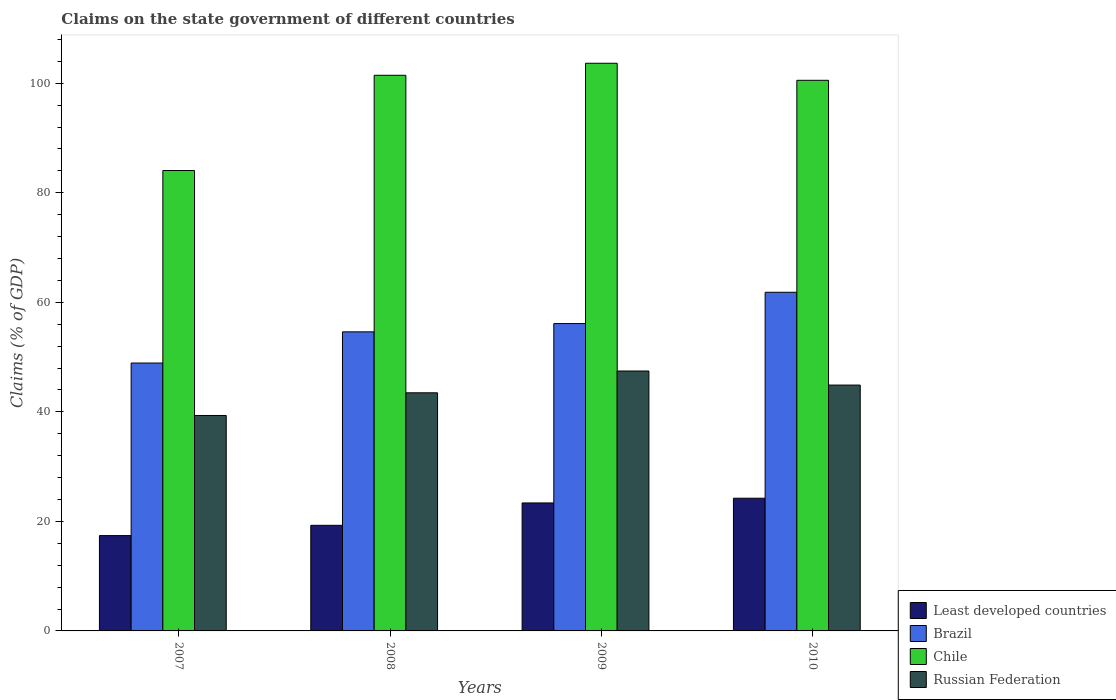How many groups of bars are there?
Keep it short and to the point. 4. Are the number of bars per tick equal to the number of legend labels?
Give a very brief answer. Yes. In how many cases, is the number of bars for a given year not equal to the number of legend labels?
Give a very brief answer. 0. What is the percentage of GDP claimed on the state government in Brazil in 2010?
Provide a short and direct response. 61.83. Across all years, what is the maximum percentage of GDP claimed on the state government in Chile?
Your answer should be compact. 103.65. Across all years, what is the minimum percentage of GDP claimed on the state government in Least developed countries?
Ensure brevity in your answer.  17.41. In which year was the percentage of GDP claimed on the state government in Brazil minimum?
Offer a very short reply. 2007. What is the total percentage of GDP claimed on the state government in Russian Federation in the graph?
Offer a very short reply. 175.15. What is the difference between the percentage of GDP claimed on the state government in Least developed countries in 2009 and that in 2010?
Provide a succinct answer. -0.86. What is the difference between the percentage of GDP claimed on the state government in Brazil in 2007 and the percentage of GDP claimed on the state government in Russian Federation in 2010?
Your answer should be very brief. 4.02. What is the average percentage of GDP claimed on the state government in Chile per year?
Provide a short and direct response. 97.42. In the year 2009, what is the difference between the percentage of GDP claimed on the state government in Chile and percentage of GDP claimed on the state government in Brazil?
Provide a short and direct response. 47.53. What is the ratio of the percentage of GDP claimed on the state government in Chile in 2008 to that in 2010?
Provide a short and direct response. 1.01. Is the percentage of GDP claimed on the state government in Chile in 2007 less than that in 2010?
Make the answer very short. Yes. What is the difference between the highest and the second highest percentage of GDP claimed on the state government in Brazil?
Offer a terse response. 5.71. What is the difference between the highest and the lowest percentage of GDP claimed on the state government in Brazil?
Offer a terse response. 12.92. In how many years, is the percentage of GDP claimed on the state government in Chile greater than the average percentage of GDP claimed on the state government in Chile taken over all years?
Provide a succinct answer. 3. Is the sum of the percentage of GDP claimed on the state government in Brazil in 2007 and 2008 greater than the maximum percentage of GDP claimed on the state government in Least developed countries across all years?
Your answer should be compact. Yes. What does the 1st bar from the left in 2008 represents?
Provide a short and direct response. Least developed countries. Are all the bars in the graph horizontal?
Your answer should be very brief. No. What is the difference between two consecutive major ticks on the Y-axis?
Ensure brevity in your answer.  20. Are the values on the major ticks of Y-axis written in scientific E-notation?
Make the answer very short. No. Does the graph contain any zero values?
Ensure brevity in your answer.  No. What is the title of the graph?
Offer a terse response. Claims on the state government of different countries. What is the label or title of the Y-axis?
Ensure brevity in your answer.  Claims (% of GDP). What is the Claims (% of GDP) of Least developed countries in 2007?
Your answer should be compact. 17.41. What is the Claims (% of GDP) of Brazil in 2007?
Provide a short and direct response. 48.91. What is the Claims (% of GDP) in Chile in 2007?
Keep it short and to the point. 84.06. What is the Claims (% of GDP) in Russian Federation in 2007?
Provide a succinct answer. 39.34. What is the Claims (% of GDP) of Least developed countries in 2008?
Your answer should be compact. 19.28. What is the Claims (% of GDP) of Brazil in 2008?
Your answer should be compact. 54.61. What is the Claims (% of GDP) of Chile in 2008?
Your response must be concise. 101.45. What is the Claims (% of GDP) in Russian Federation in 2008?
Your response must be concise. 43.48. What is the Claims (% of GDP) in Least developed countries in 2009?
Your answer should be compact. 23.37. What is the Claims (% of GDP) of Brazil in 2009?
Your answer should be very brief. 56.12. What is the Claims (% of GDP) in Chile in 2009?
Provide a succinct answer. 103.65. What is the Claims (% of GDP) in Russian Federation in 2009?
Make the answer very short. 47.45. What is the Claims (% of GDP) in Least developed countries in 2010?
Provide a short and direct response. 24.23. What is the Claims (% of GDP) of Brazil in 2010?
Offer a terse response. 61.83. What is the Claims (% of GDP) of Chile in 2010?
Give a very brief answer. 100.53. What is the Claims (% of GDP) in Russian Federation in 2010?
Provide a succinct answer. 44.89. Across all years, what is the maximum Claims (% of GDP) in Least developed countries?
Ensure brevity in your answer.  24.23. Across all years, what is the maximum Claims (% of GDP) of Brazil?
Your response must be concise. 61.83. Across all years, what is the maximum Claims (% of GDP) of Chile?
Make the answer very short. 103.65. Across all years, what is the maximum Claims (% of GDP) in Russian Federation?
Your answer should be very brief. 47.45. Across all years, what is the minimum Claims (% of GDP) in Least developed countries?
Ensure brevity in your answer.  17.41. Across all years, what is the minimum Claims (% of GDP) in Brazil?
Ensure brevity in your answer.  48.91. Across all years, what is the minimum Claims (% of GDP) of Chile?
Make the answer very short. 84.06. Across all years, what is the minimum Claims (% of GDP) in Russian Federation?
Offer a terse response. 39.34. What is the total Claims (% of GDP) in Least developed countries in the graph?
Make the answer very short. 84.28. What is the total Claims (% of GDP) of Brazil in the graph?
Offer a very short reply. 221.47. What is the total Claims (% of GDP) in Chile in the graph?
Provide a succinct answer. 389.69. What is the total Claims (% of GDP) in Russian Federation in the graph?
Your answer should be very brief. 175.15. What is the difference between the Claims (% of GDP) in Least developed countries in 2007 and that in 2008?
Your answer should be very brief. -1.88. What is the difference between the Claims (% of GDP) in Brazil in 2007 and that in 2008?
Your answer should be very brief. -5.69. What is the difference between the Claims (% of GDP) in Chile in 2007 and that in 2008?
Make the answer very short. -17.39. What is the difference between the Claims (% of GDP) of Russian Federation in 2007 and that in 2008?
Provide a short and direct response. -4.14. What is the difference between the Claims (% of GDP) of Least developed countries in 2007 and that in 2009?
Offer a terse response. -5.96. What is the difference between the Claims (% of GDP) in Brazil in 2007 and that in 2009?
Make the answer very short. -7.2. What is the difference between the Claims (% of GDP) of Chile in 2007 and that in 2009?
Offer a very short reply. -19.58. What is the difference between the Claims (% of GDP) in Russian Federation in 2007 and that in 2009?
Provide a succinct answer. -8.12. What is the difference between the Claims (% of GDP) in Least developed countries in 2007 and that in 2010?
Your answer should be compact. -6.82. What is the difference between the Claims (% of GDP) in Brazil in 2007 and that in 2010?
Provide a short and direct response. -12.92. What is the difference between the Claims (% of GDP) in Chile in 2007 and that in 2010?
Give a very brief answer. -16.47. What is the difference between the Claims (% of GDP) of Russian Federation in 2007 and that in 2010?
Your response must be concise. -5.55. What is the difference between the Claims (% of GDP) in Least developed countries in 2008 and that in 2009?
Make the answer very short. -4.08. What is the difference between the Claims (% of GDP) in Brazil in 2008 and that in 2009?
Provide a succinct answer. -1.51. What is the difference between the Claims (% of GDP) of Chile in 2008 and that in 2009?
Provide a succinct answer. -2.19. What is the difference between the Claims (% of GDP) of Russian Federation in 2008 and that in 2009?
Your response must be concise. -3.98. What is the difference between the Claims (% of GDP) of Least developed countries in 2008 and that in 2010?
Your answer should be compact. -4.95. What is the difference between the Claims (% of GDP) of Brazil in 2008 and that in 2010?
Offer a terse response. -7.23. What is the difference between the Claims (% of GDP) in Chile in 2008 and that in 2010?
Provide a short and direct response. 0.92. What is the difference between the Claims (% of GDP) in Russian Federation in 2008 and that in 2010?
Provide a succinct answer. -1.41. What is the difference between the Claims (% of GDP) of Least developed countries in 2009 and that in 2010?
Your response must be concise. -0.86. What is the difference between the Claims (% of GDP) of Brazil in 2009 and that in 2010?
Offer a terse response. -5.71. What is the difference between the Claims (% of GDP) in Chile in 2009 and that in 2010?
Ensure brevity in your answer.  3.11. What is the difference between the Claims (% of GDP) of Russian Federation in 2009 and that in 2010?
Your response must be concise. 2.57. What is the difference between the Claims (% of GDP) of Least developed countries in 2007 and the Claims (% of GDP) of Brazil in 2008?
Your answer should be compact. -37.2. What is the difference between the Claims (% of GDP) in Least developed countries in 2007 and the Claims (% of GDP) in Chile in 2008?
Provide a succinct answer. -84.05. What is the difference between the Claims (% of GDP) of Least developed countries in 2007 and the Claims (% of GDP) of Russian Federation in 2008?
Provide a succinct answer. -26.07. What is the difference between the Claims (% of GDP) in Brazil in 2007 and the Claims (% of GDP) in Chile in 2008?
Offer a very short reply. -52.54. What is the difference between the Claims (% of GDP) in Brazil in 2007 and the Claims (% of GDP) in Russian Federation in 2008?
Offer a terse response. 5.44. What is the difference between the Claims (% of GDP) of Chile in 2007 and the Claims (% of GDP) of Russian Federation in 2008?
Your answer should be compact. 40.59. What is the difference between the Claims (% of GDP) in Least developed countries in 2007 and the Claims (% of GDP) in Brazil in 2009?
Ensure brevity in your answer.  -38.71. What is the difference between the Claims (% of GDP) of Least developed countries in 2007 and the Claims (% of GDP) of Chile in 2009?
Your response must be concise. -86.24. What is the difference between the Claims (% of GDP) of Least developed countries in 2007 and the Claims (% of GDP) of Russian Federation in 2009?
Give a very brief answer. -30.05. What is the difference between the Claims (% of GDP) in Brazil in 2007 and the Claims (% of GDP) in Chile in 2009?
Provide a short and direct response. -54.73. What is the difference between the Claims (% of GDP) of Brazil in 2007 and the Claims (% of GDP) of Russian Federation in 2009?
Your answer should be compact. 1.46. What is the difference between the Claims (% of GDP) of Chile in 2007 and the Claims (% of GDP) of Russian Federation in 2009?
Your answer should be compact. 36.61. What is the difference between the Claims (% of GDP) in Least developed countries in 2007 and the Claims (% of GDP) in Brazil in 2010?
Your response must be concise. -44.42. What is the difference between the Claims (% of GDP) of Least developed countries in 2007 and the Claims (% of GDP) of Chile in 2010?
Make the answer very short. -83.13. What is the difference between the Claims (% of GDP) in Least developed countries in 2007 and the Claims (% of GDP) in Russian Federation in 2010?
Provide a succinct answer. -27.48. What is the difference between the Claims (% of GDP) of Brazil in 2007 and the Claims (% of GDP) of Chile in 2010?
Provide a succinct answer. -51.62. What is the difference between the Claims (% of GDP) of Brazil in 2007 and the Claims (% of GDP) of Russian Federation in 2010?
Provide a succinct answer. 4.02. What is the difference between the Claims (% of GDP) of Chile in 2007 and the Claims (% of GDP) of Russian Federation in 2010?
Give a very brief answer. 39.17. What is the difference between the Claims (% of GDP) of Least developed countries in 2008 and the Claims (% of GDP) of Brazil in 2009?
Offer a terse response. -36.84. What is the difference between the Claims (% of GDP) in Least developed countries in 2008 and the Claims (% of GDP) in Chile in 2009?
Your answer should be compact. -84.36. What is the difference between the Claims (% of GDP) in Least developed countries in 2008 and the Claims (% of GDP) in Russian Federation in 2009?
Your response must be concise. -28.17. What is the difference between the Claims (% of GDP) in Brazil in 2008 and the Claims (% of GDP) in Chile in 2009?
Make the answer very short. -49.04. What is the difference between the Claims (% of GDP) in Brazil in 2008 and the Claims (% of GDP) in Russian Federation in 2009?
Make the answer very short. 7.15. What is the difference between the Claims (% of GDP) in Chile in 2008 and the Claims (% of GDP) in Russian Federation in 2009?
Your answer should be very brief. 54. What is the difference between the Claims (% of GDP) in Least developed countries in 2008 and the Claims (% of GDP) in Brazil in 2010?
Offer a very short reply. -42.55. What is the difference between the Claims (% of GDP) in Least developed countries in 2008 and the Claims (% of GDP) in Chile in 2010?
Keep it short and to the point. -81.25. What is the difference between the Claims (% of GDP) in Least developed countries in 2008 and the Claims (% of GDP) in Russian Federation in 2010?
Your answer should be compact. -25.61. What is the difference between the Claims (% of GDP) in Brazil in 2008 and the Claims (% of GDP) in Chile in 2010?
Ensure brevity in your answer.  -45.93. What is the difference between the Claims (% of GDP) in Brazil in 2008 and the Claims (% of GDP) in Russian Federation in 2010?
Your answer should be compact. 9.72. What is the difference between the Claims (% of GDP) of Chile in 2008 and the Claims (% of GDP) of Russian Federation in 2010?
Give a very brief answer. 56.56. What is the difference between the Claims (% of GDP) of Least developed countries in 2009 and the Claims (% of GDP) of Brazil in 2010?
Make the answer very short. -38.46. What is the difference between the Claims (% of GDP) in Least developed countries in 2009 and the Claims (% of GDP) in Chile in 2010?
Keep it short and to the point. -77.17. What is the difference between the Claims (% of GDP) of Least developed countries in 2009 and the Claims (% of GDP) of Russian Federation in 2010?
Provide a succinct answer. -21.52. What is the difference between the Claims (% of GDP) in Brazil in 2009 and the Claims (% of GDP) in Chile in 2010?
Offer a very short reply. -44.42. What is the difference between the Claims (% of GDP) in Brazil in 2009 and the Claims (% of GDP) in Russian Federation in 2010?
Your response must be concise. 11.23. What is the difference between the Claims (% of GDP) of Chile in 2009 and the Claims (% of GDP) of Russian Federation in 2010?
Keep it short and to the point. 58.76. What is the average Claims (% of GDP) in Least developed countries per year?
Provide a short and direct response. 21.07. What is the average Claims (% of GDP) of Brazil per year?
Keep it short and to the point. 55.37. What is the average Claims (% of GDP) in Chile per year?
Provide a short and direct response. 97.42. What is the average Claims (% of GDP) in Russian Federation per year?
Your answer should be compact. 43.79. In the year 2007, what is the difference between the Claims (% of GDP) in Least developed countries and Claims (% of GDP) in Brazil?
Your answer should be compact. -31.51. In the year 2007, what is the difference between the Claims (% of GDP) of Least developed countries and Claims (% of GDP) of Chile?
Ensure brevity in your answer.  -66.65. In the year 2007, what is the difference between the Claims (% of GDP) in Least developed countries and Claims (% of GDP) in Russian Federation?
Your answer should be very brief. -21.93. In the year 2007, what is the difference between the Claims (% of GDP) of Brazil and Claims (% of GDP) of Chile?
Make the answer very short. -35.15. In the year 2007, what is the difference between the Claims (% of GDP) in Brazil and Claims (% of GDP) in Russian Federation?
Provide a short and direct response. 9.58. In the year 2007, what is the difference between the Claims (% of GDP) of Chile and Claims (% of GDP) of Russian Federation?
Offer a very short reply. 44.72. In the year 2008, what is the difference between the Claims (% of GDP) in Least developed countries and Claims (% of GDP) in Brazil?
Ensure brevity in your answer.  -35.32. In the year 2008, what is the difference between the Claims (% of GDP) of Least developed countries and Claims (% of GDP) of Chile?
Make the answer very short. -82.17. In the year 2008, what is the difference between the Claims (% of GDP) of Least developed countries and Claims (% of GDP) of Russian Federation?
Offer a terse response. -24.19. In the year 2008, what is the difference between the Claims (% of GDP) in Brazil and Claims (% of GDP) in Chile?
Your answer should be compact. -46.85. In the year 2008, what is the difference between the Claims (% of GDP) in Brazil and Claims (% of GDP) in Russian Federation?
Provide a succinct answer. 11.13. In the year 2008, what is the difference between the Claims (% of GDP) in Chile and Claims (% of GDP) in Russian Federation?
Provide a succinct answer. 57.98. In the year 2009, what is the difference between the Claims (% of GDP) of Least developed countries and Claims (% of GDP) of Brazil?
Give a very brief answer. -32.75. In the year 2009, what is the difference between the Claims (% of GDP) of Least developed countries and Claims (% of GDP) of Chile?
Keep it short and to the point. -80.28. In the year 2009, what is the difference between the Claims (% of GDP) in Least developed countries and Claims (% of GDP) in Russian Federation?
Your response must be concise. -24.09. In the year 2009, what is the difference between the Claims (% of GDP) of Brazil and Claims (% of GDP) of Chile?
Give a very brief answer. -47.53. In the year 2009, what is the difference between the Claims (% of GDP) in Brazil and Claims (% of GDP) in Russian Federation?
Make the answer very short. 8.66. In the year 2009, what is the difference between the Claims (% of GDP) in Chile and Claims (% of GDP) in Russian Federation?
Offer a terse response. 56.19. In the year 2010, what is the difference between the Claims (% of GDP) in Least developed countries and Claims (% of GDP) in Brazil?
Provide a short and direct response. -37.6. In the year 2010, what is the difference between the Claims (% of GDP) of Least developed countries and Claims (% of GDP) of Chile?
Keep it short and to the point. -76.3. In the year 2010, what is the difference between the Claims (% of GDP) in Least developed countries and Claims (% of GDP) in Russian Federation?
Give a very brief answer. -20.66. In the year 2010, what is the difference between the Claims (% of GDP) of Brazil and Claims (% of GDP) of Chile?
Provide a succinct answer. -38.7. In the year 2010, what is the difference between the Claims (% of GDP) of Brazil and Claims (% of GDP) of Russian Federation?
Keep it short and to the point. 16.94. In the year 2010, what is the difference between the Claims (% of GDP) in Chile and Claims (% of GDP) in Russian Federation?
Offer a very short reply. 55.64. What is the ratio of the Claims (% of GDP) of Least developed countries in 2007 to that in 2008?
Offer a very short reply. 0.9. What is the ratio of the Claims (% of GDP) of Brazil in 2007 to that in 2008?
Give a very brief answer. 0.9. What is the ratio of the Claims (% of GDP) of Chile in 2007 to that in 2008?
Give a very brief answer. 0.83. What is the ratio of the Claims (% of GDP) in Russian Federation in 2007 to that in 2008?
Offer a terse response. 0.9. What is the ratio of the Claims (% of GDP) in Least developed countries in 2007 to that in 2009?
Your response must be concise. 0.74. What is the ratio of the Claims (% of GDP) in Brazil in 2007 to that in 2009?
Give a very brief answer. 0.87. What is the ratio of the Claims (% of GDP) of Chile in 2007 to that in 2009?
Ensure brevity in your answer.  0.81. What is the ratio of the Claims (% of GDP) of Russian Federation in 2007 to that in 2009?
Provide a succinct answer. 0.83. What is the ratio of the Claims (% of GDP) in Least developed countries in 2007 to that in 2010?
Your answer should be very brief. 0.72. What is the ratio of the Claims (% of GDP) in Brazil in 2007 to that in 2010?
Your response must be concise. 0.79. What is the ratio of the Claims (% of GDP) in Chile in 2007 to that in 2010?
Keep it short and to the point. 0.84. What is the ratio of the Claims (% of GDP) in Russian Federation in 2007 to that in 2010?
Give a very brief answer. 0.88. What is the ratio of the Claims (% of GDP) of Least developed countries in 2008 to that in 2009?
Make the answer very short. 0.83. What is the ratio of the Claims (% of GDP) of Brazil in 2008 to that in 2009?
Give a very brief answer. 0.97. What is the ratio of the Claims (% of GDP) in Chile in 2008 to that in 2009?
Offer a very short reply. 0.98. What is the ratio of the Claims (% of GDP) in Russian Federation in 2008 to that in 2009?
Keep it short and to the point. 0.92. What is the ratio of the Claims (% of GDP) of Least developed countries in 2008 to that in 2010?
Provide a short and direct response. 0.8. What is the ratio of the Claims (% of GDP) in Brazil in 2008 to that in 2010?
Your response must be concise. 0.88. What is the ratio of the Claims (% of GDP) in Chile in 2008 to that in 2010?
Your answer should be compact. 1.01. What is the ratio of the Claims (% of GDP) of Russian Federation in 2008 to that in 2010?
Your answer should be very brief. 0.97. What is the ratio of the Claims (% of GDP) of Least developed countries in 2009 to that in 2010?
Ensure brevity in your answer.  0.96. What is the ratio of the Claims (% of GDP) in Brazil in 2009 to that in 2010?
Ensure brevity in your answer.  0.91. What is the ratio of the Claims (% of GDP) in Chile in 2009 to that in 2010?
Your answer should be very brief. 1.03. What is the ratio of the Claims (% of GDP) in Russian Federation in 2009 to that in 2010?
Your answer should be compact. 1.06. What is the difference between the highest and the second highest Claims (% of GDP) in Least developed countries?
Offer a terse response. 0.86. What is the difference between the highest and the second highest Claims (% of GDP) of Brazil?
Provide a short and direct response. 5.71. What is the difference between the highest and the second highest Claims (% of GDP) in Chile?
Your response must be concise. 2.19. What is the difference between the highest and the second highest Claims (% of GDP) in Russian Federation?
Make the answer very short. 2.57. What is the difference between the highest and the lowest Claims (% of GDP) in Least developed countries?
Offer a very short reply. 6.82. What is the difference between the highest and the lowest Claims (% of GDP) of Brazil?
Ensure brevity in your answer.  12.92. What is the difference between the highest and the lowest Claims (% of GDP) in Chile?
Offer a very short reply. 19.58. What is the difference between the highest and the lowest Claims (% of GDP) of Russian Federation?
Your response must be concise. 8.12. 